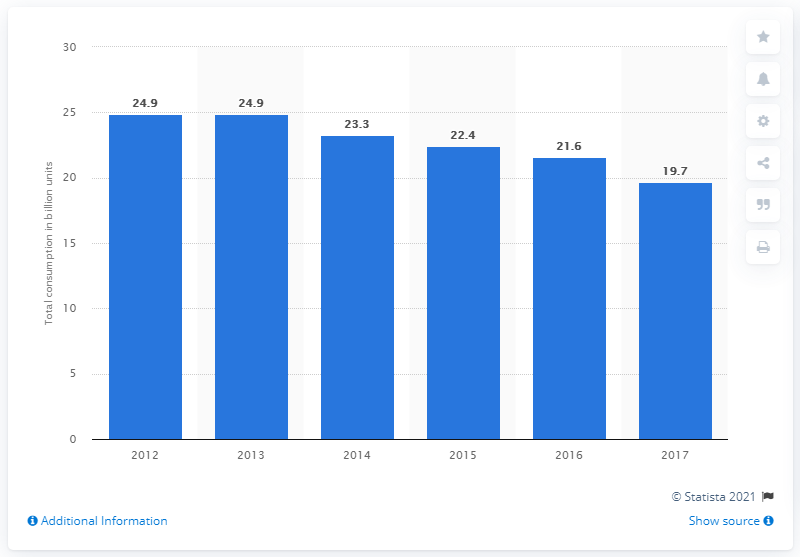Identify some key points in this picture. In 2017, a total of 19.7 billion cigarettes were consumed in Australia. 